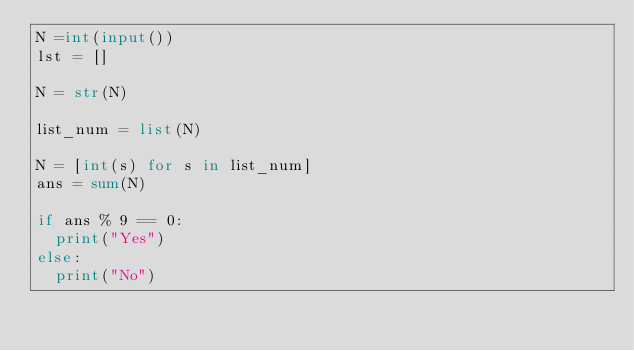Convert code to text. <code><loc_0><loc_0><loc_500><loc_500><_Python_>N =int(input())
lst = []

N = str(N)

list_num = list(N)

N = [int(s) for s in list_num]
ans = sum(N)

if ans % 9 == 0:
  print("Yes")
else:
  print("No")</code> 